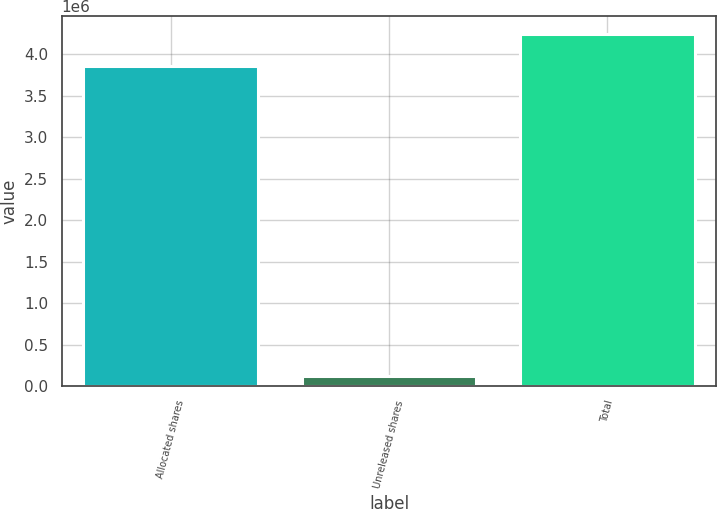Convert chart to OTSL. <chart><loc_0><loc_0><loc_500><loc_500><bar_chart><fcel>Allocated shares<fcel>Unreleased shares<fcel>Total<nl><fcel>3.85704e+06<fcel>117408<fcel>4.24274e+06<nl></chart> 